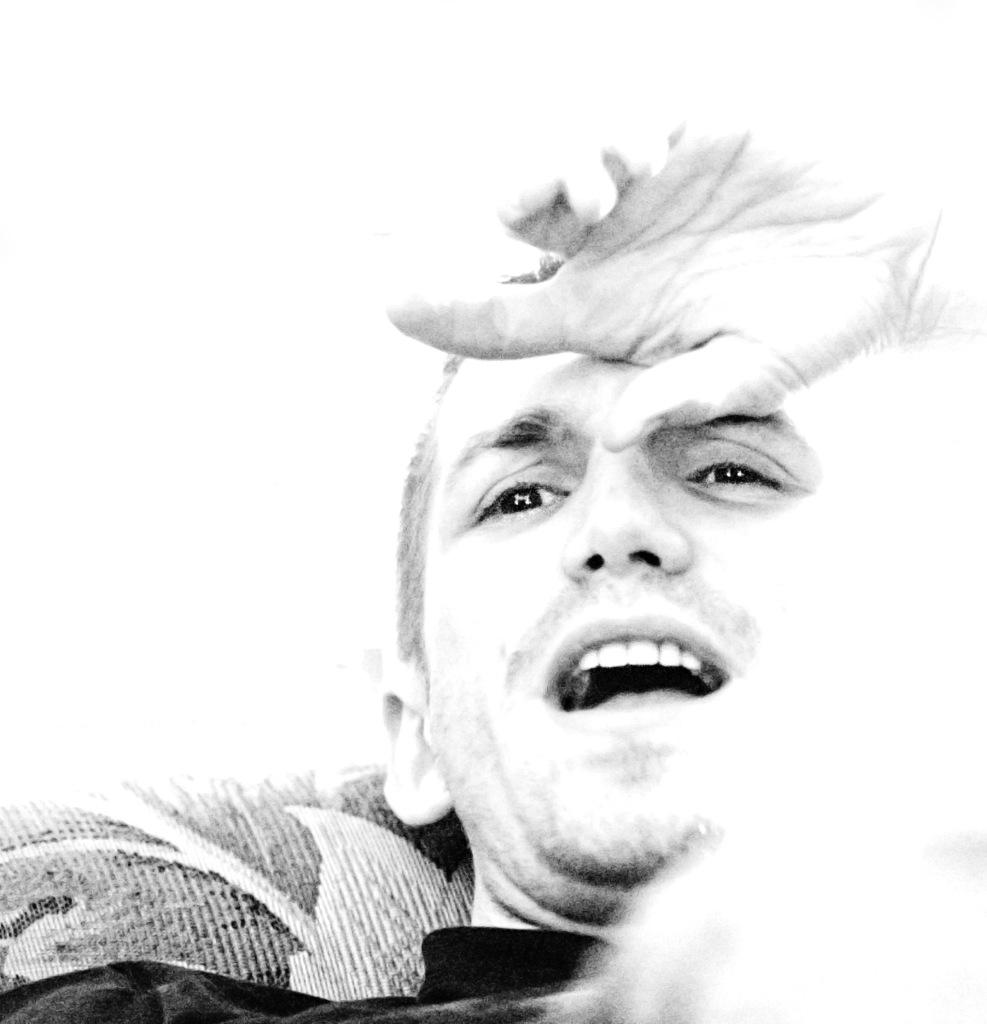What can be observed about the image's appearance? The image is edited. Can you describe the main subject in the image? There is a person in the image. How many masses can be seen in the image? There is no mass present in the image. What type of dog is sitting next to the person in the image? There is no dog present in the image. 